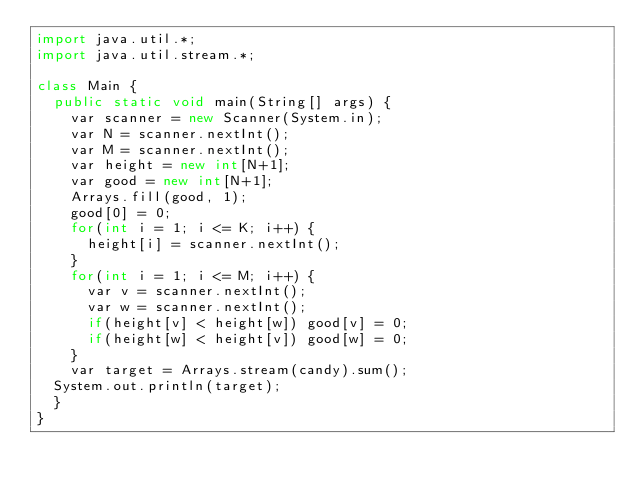<code> <loc_0><loc_0><loc_500><loc_500><_Java_>import java.util.*;
import java.util.stream.*;

class Main {
  public static void main(String[] args) {
    var scanner = new Scanner(System.in);
    var N = scanner.nextInt();
    var M = scanner.nextInt();
    var height = new int[N+1];
    var good = new int[N+1];
    Arrays.fill(good, 1);
    good[0] = 0;
    for(int i = 1; i <= K; i++) {
      height[i] = scanner.nextInt();
    }
    for(int i = 1; i <= M; i++) {
      var v = scanner.nextInt();
      var w = scanner.nextInt();
      if(height[v] < height[w]) good[v] = 0;
      if(height[w] < height[v]) good[w] = 0;
    }
    var target = Arrays.stream(candy).sum();
	System.out.println(target);
  }
}
</code> 